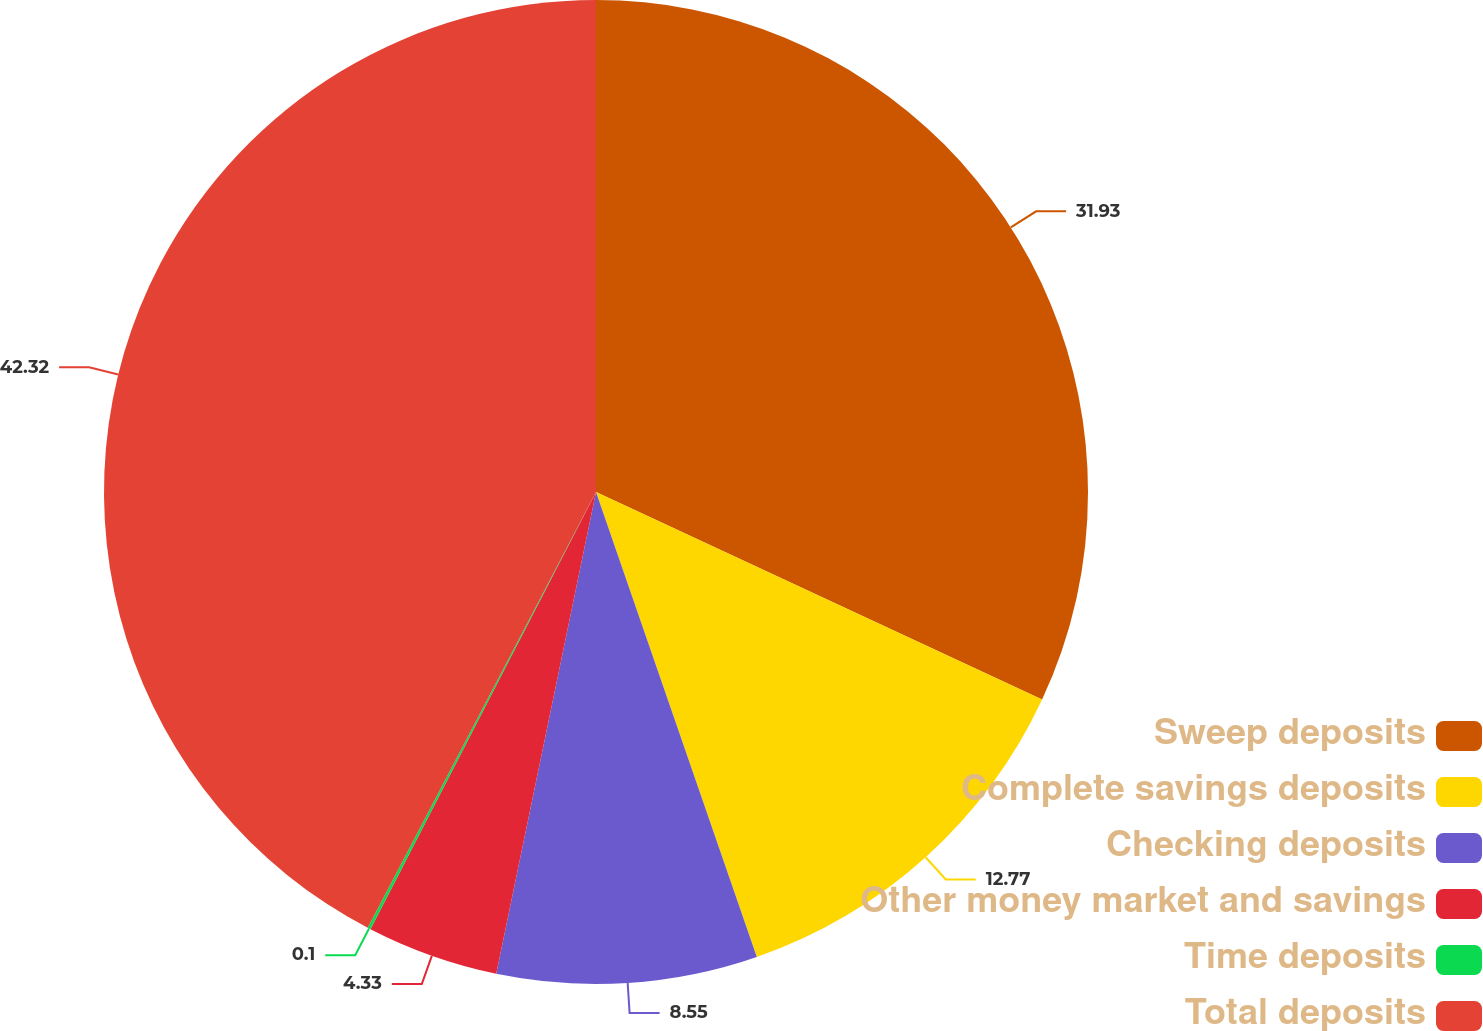Convert chart to OTSL. <chart><loc_0><loc_0><loc_500><loc_500><pie_chart><fcel>Sweep deposits<fcel>Complete savings deposits<fcel>Checking deposits<fcel>Other money market and savings<fcel>Time deposits<fcel>Total deposits<nl><fcel>31.93%<fcel>12.77%<fcel>8.55%<fcel>4.33%<fcel>0.1%<fcel>42.32%<nl></chart> 